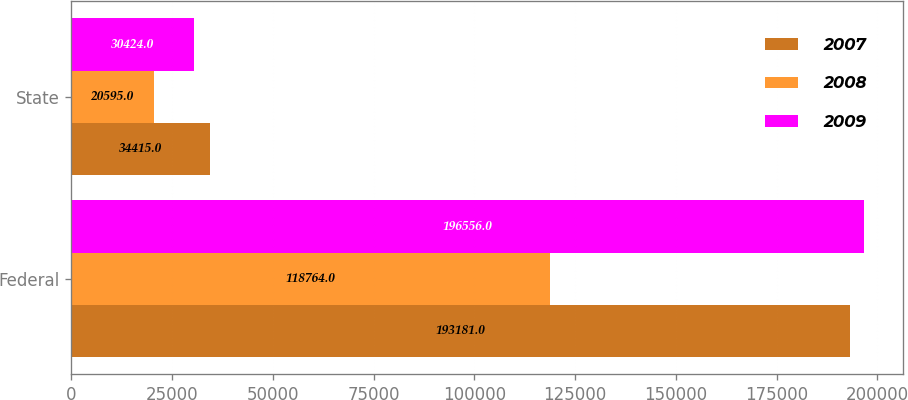<chart> <loc_0><loc_0><loc_500><loc_500><stacked_bar_chart><ecel><fcel>Federal<fcel>State<nl><fcel>2007<fcel>193181<fcel>34415<nl><fcel>2008<fcel>118764<fcel>20595<nl><fcel>2009<fcel>196556<fcel>30424<nl></chart> 